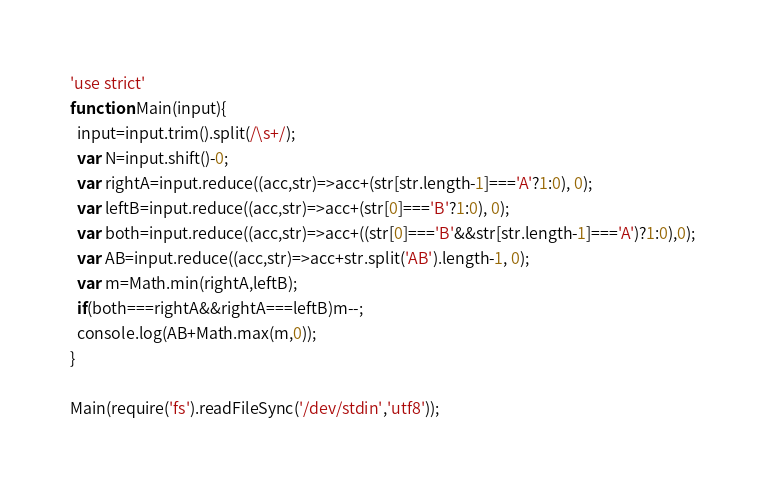<code> <loc_0><loc_0><loc_500><loc_500><_JavaScript_>'use strict'
function Main(input){
  input=input.trim().split(/\s+/);
  var N=input.shift()-0;
  var rightA=input.reduce((acc,str)=>acc+(str[str.length-1]==='A'?1:0), 0);
  var leftB=input.reduce((acc,str)=>acc+(str[0]==='B'?1:0), 0);
  var both=input.reduce((acc,str)=>acc+((str[0]==='B'&&str[str.length-1]==='A')?1:0),0);
  var AB=input.reduce((acc,str)=>acc+str.split('AB').length-1, 0);
  var m=Math.min(rightA,leftB);
  if(both===rightA&&rightA===leftB)m--;
  console.log(AB+Math.max(m,0));
}

Main(require('fs').readFileSync('/dev/stdin','utf8'));
</code> 